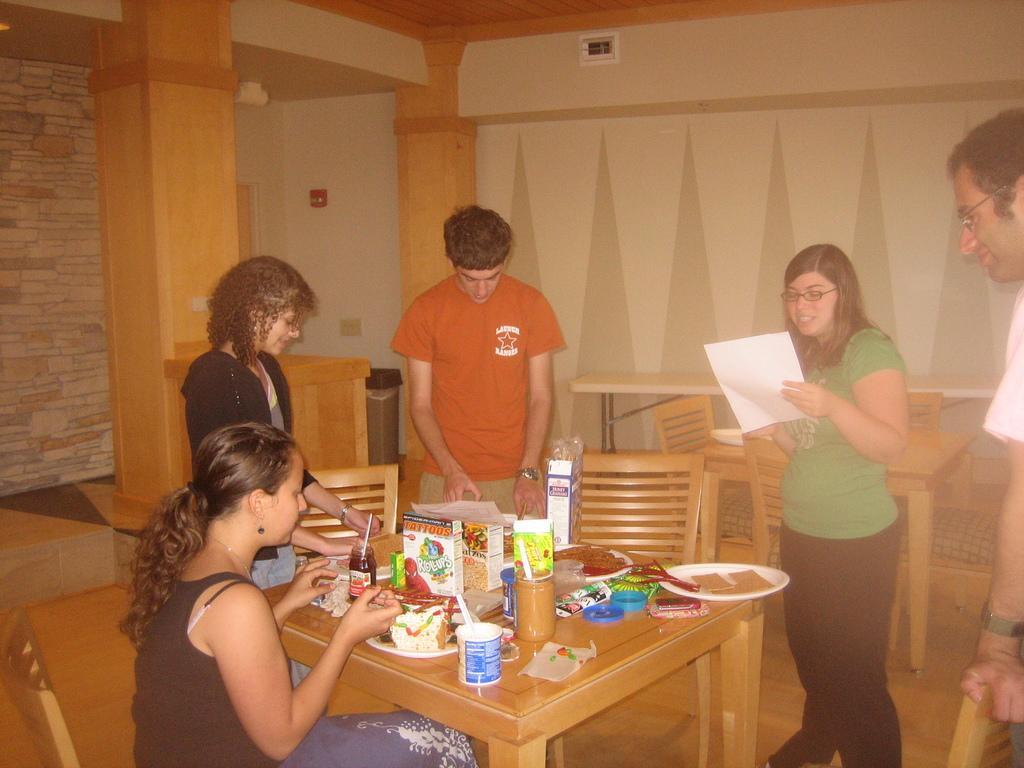Please provide a concise description of this image. There are four people standing and one women sitting on the chair. This is a table with some food items and some objects on it. I can see some empty chairs. This looks like a dustbin. This is a pillar. 